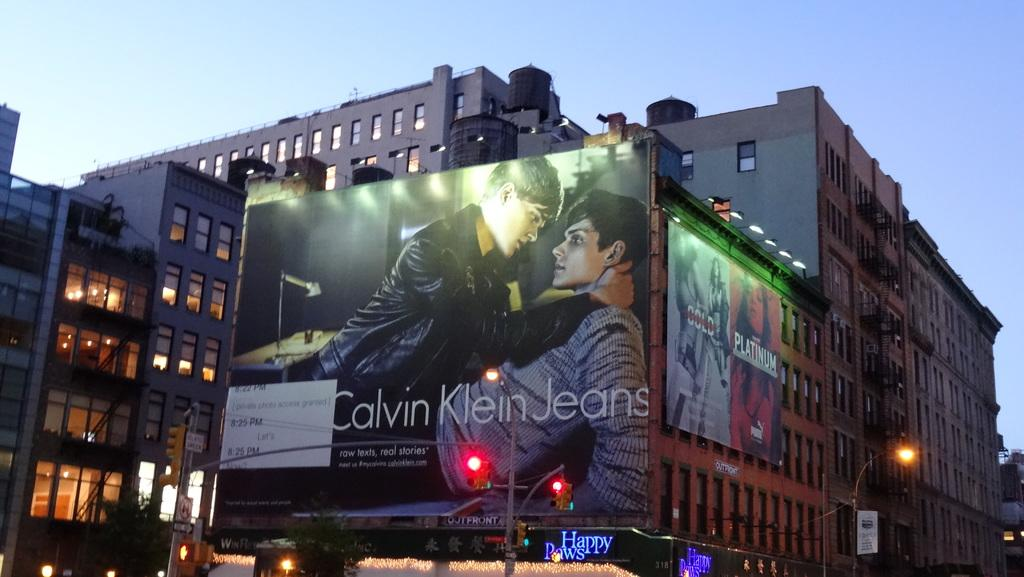<image>
Provide a brief description of the given image. An advertisement for jeans from the company Calvin Klein 